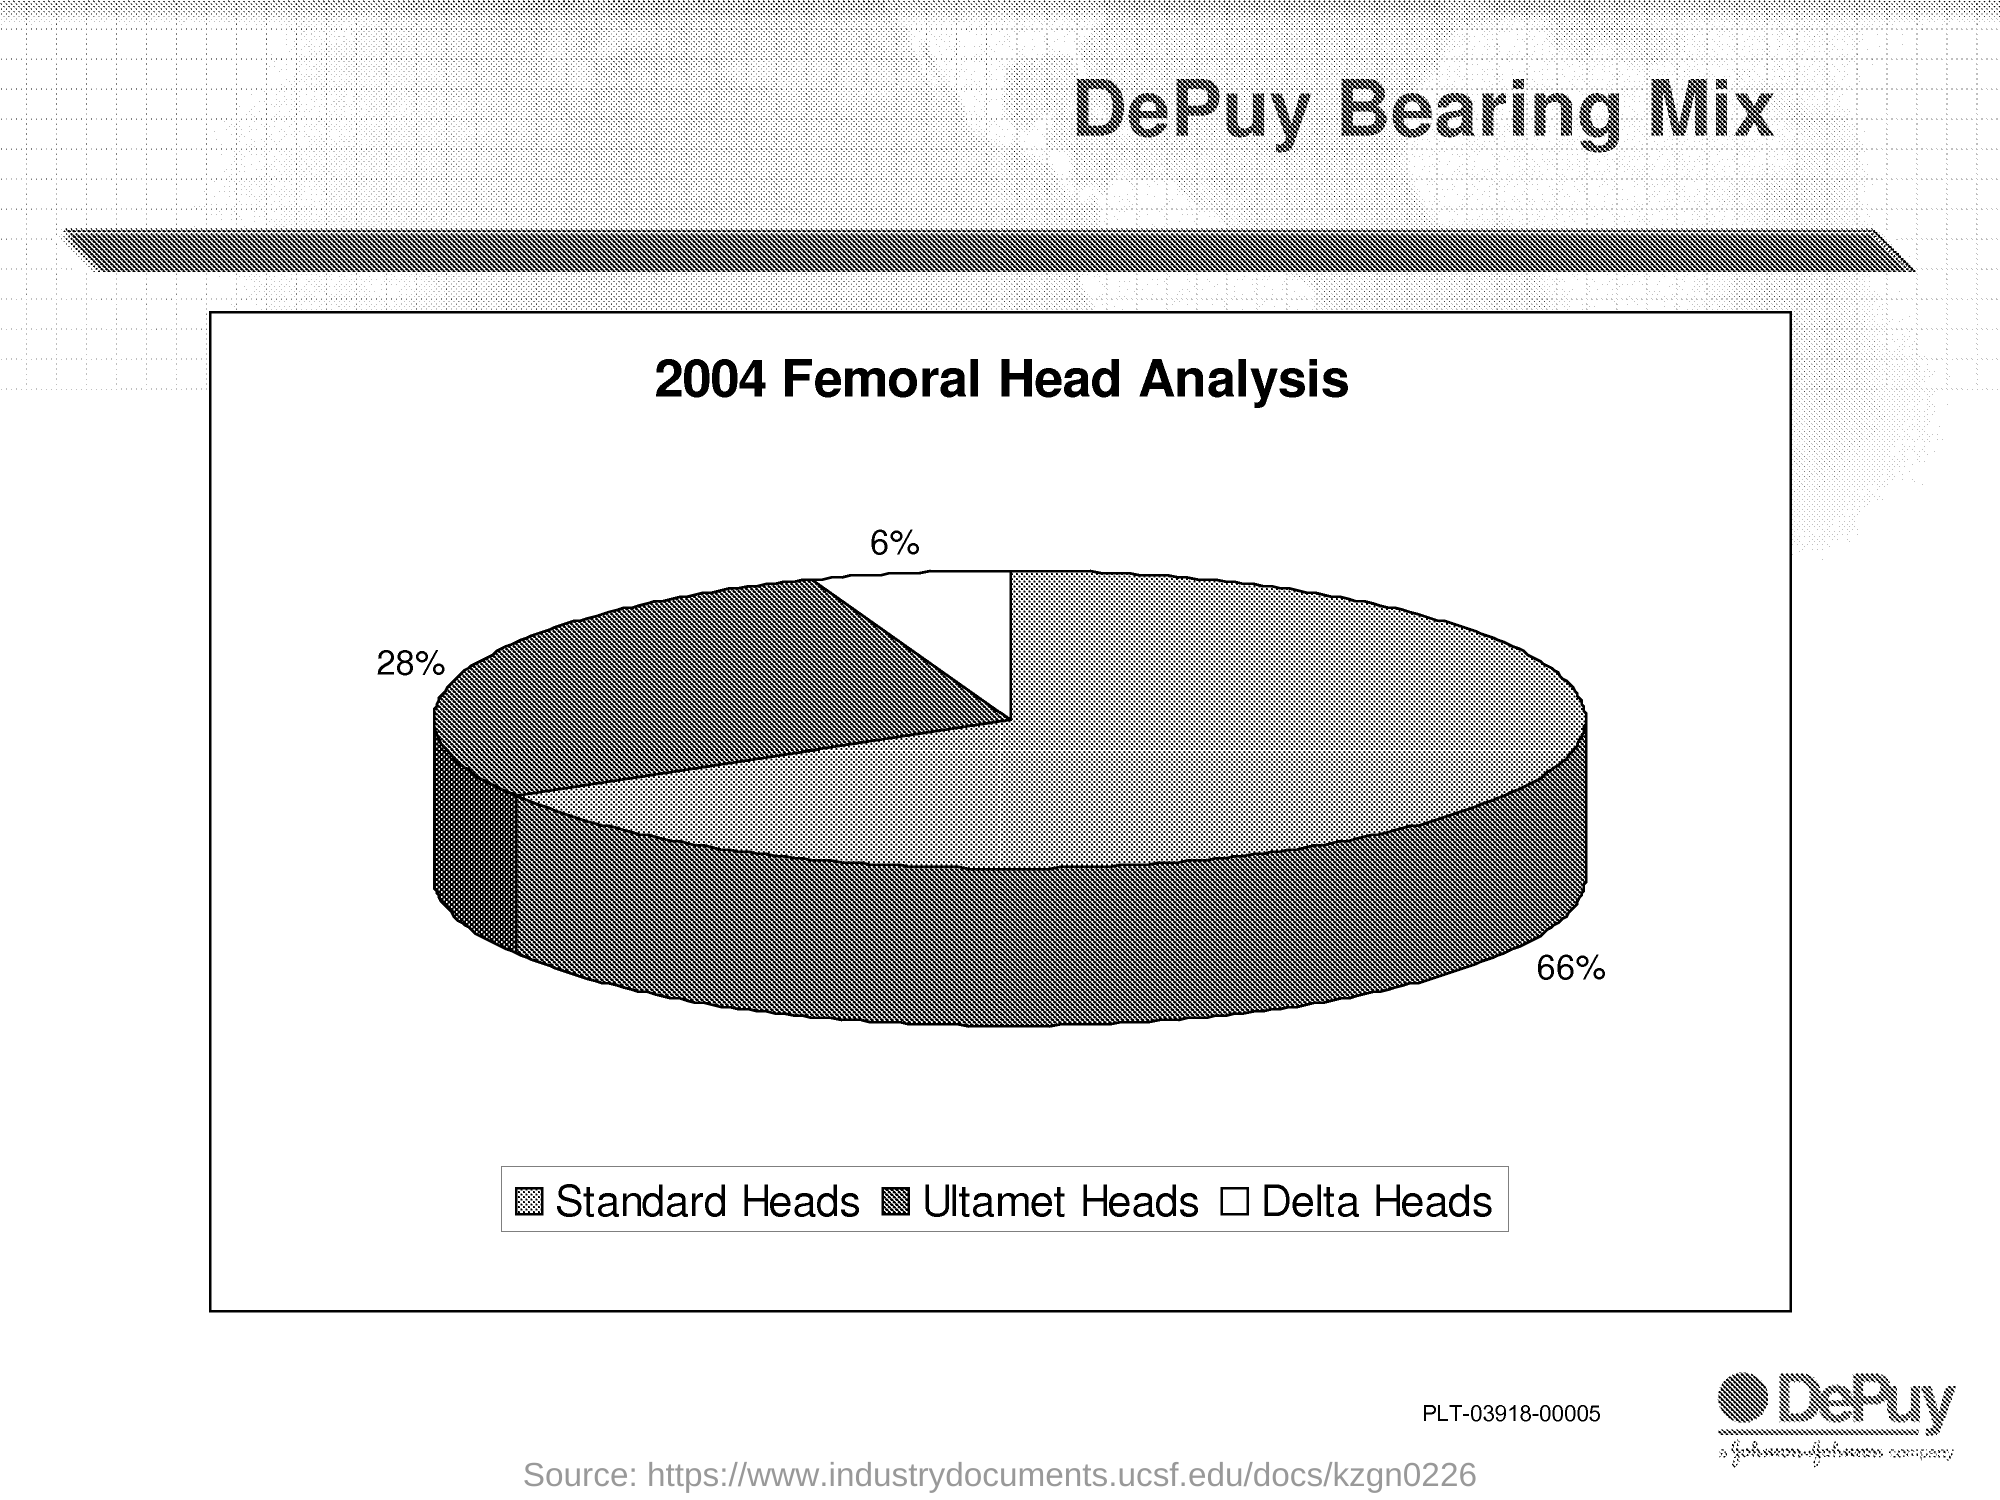Point out several critical features in this image. Approximately 66% of the Standard heads are depicted in the piechart. The title of this pie chart is '2004 Femoral Head Analysis.' Approximately 28% of the Ultamet heads were shown on the pie chart. Approximately 6% of the Delta heads are represented in the pie chart. 